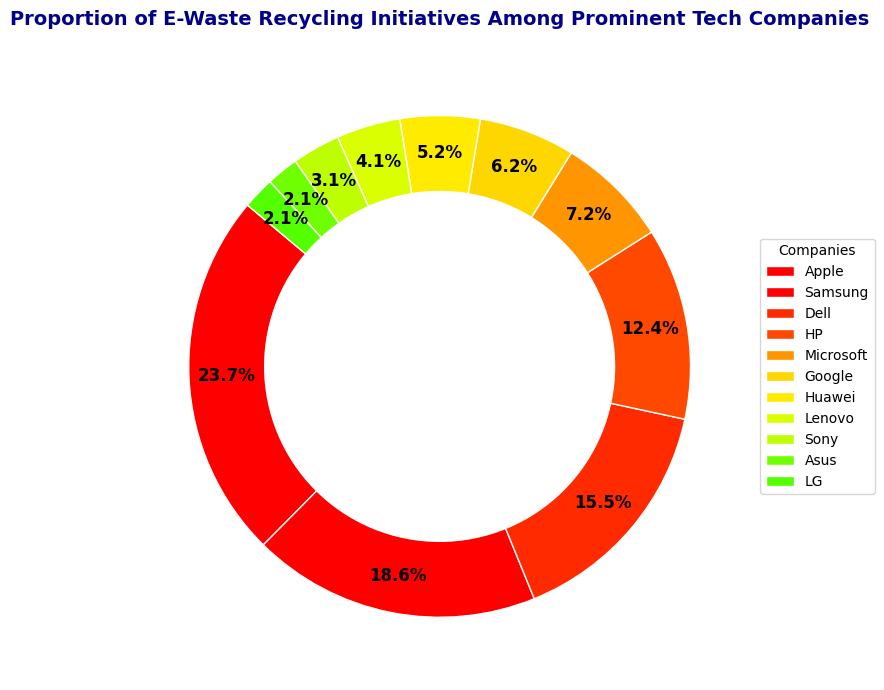Which company has the highest proportion of e-waste recycling initiatives? The figure shows the proportion of e-waste recycling initiatives for different companies. The company with the largest segment in the ring chart represents the highest proportion.
Answer: Apple What is the total proportion of e-waste recycling initiatives for Samsung and Dell combined? To find the combined proportion, sum the individual proportions. Samsung has 18 initiatives and Dell has 15, so (18 + 15) = 33. Calculate the proportion of this sum out of the total (95 initiatives) which is (33/95) * 100%.
Answer: 34.7% How does the proportion of HP's e-waste recycling initiatives compare to Google's? Compare the size of the segments corresponding to HP and Google. HP has 12 initiatives and Google has 6, hence HP's proportion is larger than Google's.
Answer: HP's proportion is larger What proportion of e-waste recycling initiatives are from companies with fewer than 5 initiatives? Identify the companies with fewer than 5 initiatives (Lenovo, Sony, Asus, LG) and add their initiatives: (4+3+2+2) = 11. Calculate the proportion of this sum out of the total (95 initiatives) which is (11/95) * 100%.
Answer: 11.6% Which company has the smallest segment in the ring chart? The smallest segment corresponds to the company with the fewest initiatives. The figure shows that both Asus and LG have the smallest segments, each with 2 initiatives.
Answer: Asus and LG What is the average number of initiatives per company? The total number of initiatives is 95, spread across 11 companies. To find the average, divide the total initiatives by the number of companies: 95/11.
Answer: 8.64 Is the sum of initiatives from Microsoft and Huawei greater than those from Apple? Microsoft has 7 initiatives and Huawei has 5, so combined they have (7 + 5) = 12. Apple alone has 23 initiatives. Compare 12 with 23.
Answer: No What is the difference in the number of initiatives between Apple and the total of Sony and Lenovo combined? Apple has 23 initiatives. Sony and Lenovo together have (3 + 4) = 7 initiatives. The difference is (23 - 7).
Answer: 16 Which companies have a proportion of initiatives between 5% and 10%? Calculate the individual proportions for each company and identify those within the 5%-10% range. Microsoft (7/95*100=7.4%) and Google (6/95*100=6.3%) fall within this range.
Answer: Microsoft and Google 